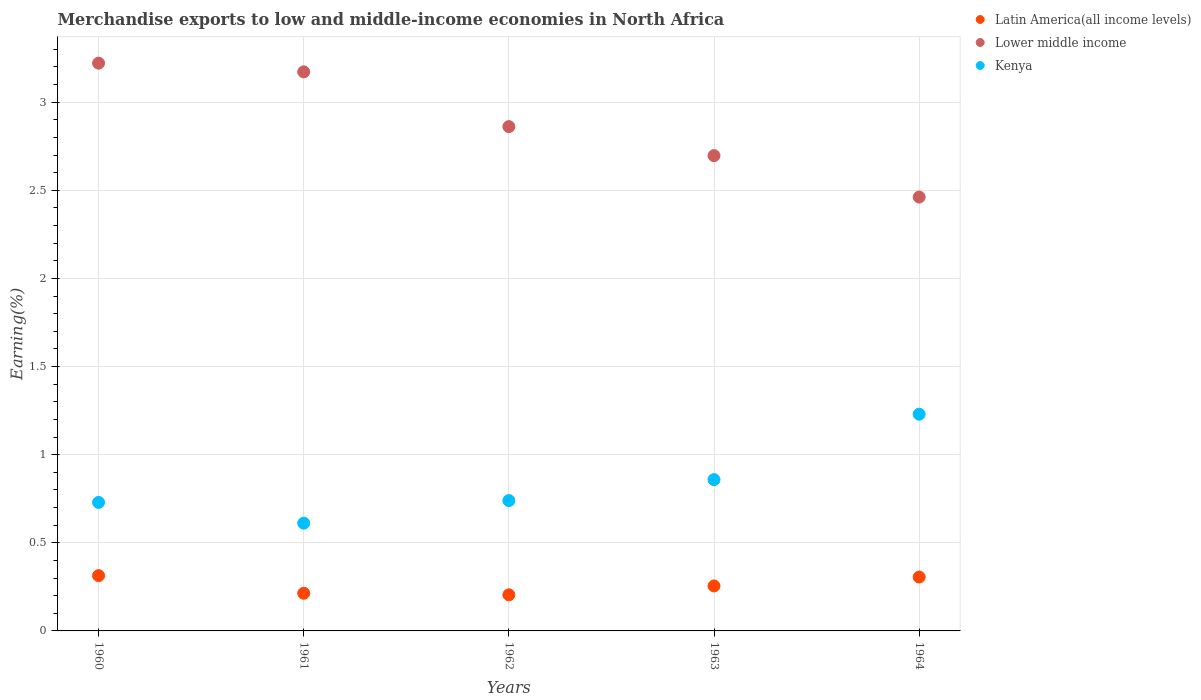How many different coloured dotlines are there?
Your response must be concise. 3. What is the percentage of amount earned from merchandise exports in Latin America(all income levels) in 1962?
Keep it short and to the point. 0.2. Across all years, what is the maximum percentage of amount earned from merchandise exports in Kenya?
Make the answer very short. 1.23. Across all years, what is the minimum percentage of amount earned from merchandise exports in Lower middle income?
Offer a terse response. 2.46. In which year was the percentage of amount earned from merchandise exports in Lower middle income maximum?
Your response must be concise. 1960. In which year was the percentage of amount earned from merchandise exports in Lower middle income minimum?
Your response must be concise. 1964. What is the total percentage of amount earned from merchandise exports in Kenya in the graph?
Your answer should be very brief. 4.17. What is the difference between the percentage of amount earned from merchandise exports in Lower middle income in 1960 and that in 1962?
Offer a very short reply. 0.36. What is the difference between the percentage of amount earned from merchandise exports in Latin America(all income levels) in 1962 and the percentage of amount earned from merchandise exports in Kenya in 1960?
Ensure brevity in your answer.  -0.52. What is the average percentage of amount earned from merchandise exports in Kenya per year?
Ensure brevity in your answer.  0.83. In the year 1963, what is the difference between the percentage of amount earned from merchandise exports in Kenya and percentage of amount earned from merchandise exports in Latin America(all income levels)?
Provide a succinct answer. 0.6. In how many years, is the percentage of amount earned from merchandise exports in Lower middle income greater than 1.5 %?
Your answer should be very brief. 5. What is the ratio of the percentage of amount earned from merchandise exports in Lower middle income in 1960 to that in 1964?
Offer a very short reply. 1.31. Is the difference between the percentage of amount earned from merchandise exports in Kenya in 1960 and 1963 greater than the difference between the percentage of amount earned from merchandise exports in Latin America(all income levels) in 1960 and 1963?
Your answer should be very brief. No. What is the difference between the highest and the second highest percentage of amount earned from merchandise exports in Lower middle income?
Your answer should be very brief. 0.05. What is the difference between the highest and the lowest percentage of amount earned from merchandise exports in Latin America(all income levels)?
Make the answer very short. 0.11. In how many years, is the percentage of amount earned from merchandise exports in Lower middle income greater than the average percentage of amount earned from merchandise exports in Lower middle income taken over all years?
Keep it short and to the point. 2. Is the percentage of amount earned from merchandise exports in Lower middle income strictly less than the percentage of amount earned from merchandise exports in Latin America(all income levels) over the years?
Provide a succinct answer. No. How many dotlines are there?
Offer a very short reply. 3. Does the graph contain any zero values?
Make the answer very short. No. Does the graph contain grids?
Offer a terse response. Yes. Where does the legend appear in the graph?
Ensure brevity in your answer.  Top right. How are the legend labels stacked?
Your response must be concise. Vertical. What is the title of the graph?
Offer a very short reply. Merchandise exports to low and middle-income economies in North Africa. What is the label or title of the X-axis?
Your response must be concise. Years. What is the label or title of the Y-axis?
Provide a short and direct response. Earning(%). What is the Earning(%) of Latin America(all income levels) in 1960?
Ensure brevity in your answer.  0.31. What is the Earning(%) in Lower middle income in 1960?
Make the answer very short. 3.22. What is the Earning(%) in Kenya in 1960?
Your response must be concise. 0.73. What is the Earning(%) in Latin America(all income levels) in 1961?
Provide a short and direct response. 0.21. What is the Earning(%) of Lower middle income in 1961?
Offer a very short reply. 3.17. What is the Earning(%) in Kenya in 1961?
Offer a very short reply. 0.61. What is the Earning(%) of Latin America(all income levels) in 1962?
Your answer should be very brief. 0.2. What is the Earning(%) in Lower middle income in 1962?
Offer a very short reply. 2.86. What is the Earning(%) in Kenya in 1962?
Provide a succinct answer. 0.74. What is the Earning(%) in Latin America(all income levels) in 1963?
Offer a very short reply. 0.26. What is the Earning(%) in Lower middle income in 1963?
Provide a short and direct response. 2.7. What is the Earning(%) in Kenya in 1963?
Provide a succinct answer. 0.86. What is the Earning(%) in Latin America(all income levels) in 1964?
Make the answer very short. 0.31. What is the Earning(%) of Lower middle income in 1964?
Provide a short and direct response. 2.46. What is the Earning(%) in Kenya in 1964?
Your answer should be compact. 1.23. Across all years, what is the maximum Earning(%) of Latin America(all income levels)?
Offer a terse response. 0.31. Across all years, what is the maximum Earning(%) in Lower middle income?
Provide a short and direct response. 3.22. Across all years, what is the maximum Earning(%) in Kenya?
Your response must be concise. 1.23. Across all years, what is the minimum Earning(%) of Latin America(all income levels)?
Your response must be concise. 0.2. Across all years, what is the minimum Earning(%) in Lower middle income?
Offer a terse response. 2.46. Across all years, what is the minimum Earning(%) of Kenya?
Your response must be concise. 0.61. What is the total Earning(%) in Latin America(all income levels) in the graph?
Your response must be concise. 1.29. What is the total Earning(%) in Lower middle income in the graph?
Your response must be concise. 14.41. What is the total Earning(%) in Kenya in the graph?
Provide a succinct answer. 4.17. What is the difference between the Earning(%) in Latin America(all income levels) in 1960 and that in 1961?
Your answer should be compact. 0.1. What is the difference between the Earning(%) of Lower middle income in 1960 and that in 1961?
Offer a very short reply. 0.05. What is the difference between the Earning(%) in Kenya in 1960 and that in 1961?
Your response must be concise. 0.12. What is the difference between the Earning(%) of Latin America(all income levels) in 1960 and that in 1962?
Your answer should be very brief. 0.11. What is the difference between the Earning(%) in Lower middle income in 1960 and that in 1962?
Make the answer very short. 0.36. What is the difference between the Earning(%) of Kenya in 1960 and that in 1962?
Your response must be concise. -0.01. What is the difference between the Earning(%) in Latin America(all income levels) in 1960 and that in 1963?
Give a very brief answer. 0.06. What is the difference between the Earning(%) of Lower middle income in 1960 and that in 1963?
Your answer should be very brief. 0.52. What is the difference between the Earning(%) of Kenya in 1960 and that in 1963?
Provide a succinct answer. -0.13. What is the difference between the Earning(%) in Latin America(all income levels) in 1960 and that in 1964?
Offer a very short reply. 0.01. What is the difference between the Earning(%) of Lower middle income in 1960 and that in 1964?
Your answer should be very brief. 0.76. What is the difference between the Earning(%) of Kenya in 1960 and that in 1964?
Make the answer very short. -0.5. What is the difference between the Earning(%) of Latin America(all income levels) in 1961 and that in 1962?
Ensure brevity in your answer.  0.01. What is the difference between the Earning(%) of Lower middle income in 1961 and that in 1962?
Offer a terse response. 0.31. What is the difference between the Earning(%) of Kenya in 1961 and that in 1962?
Provide a succinct answer. -0.13. What is the difference between the Earning(%) of Latin America(all income levels) in 1961 and that in 1963?
Your response must be concise. -0.04. What is the difference between the Earning(%) of Lower middle income in 1961 and that in 1963?
Your response must be concise. 0.48. What is the difference between the Earning(%) in Kenya in 1961 and that in 1963?
Make the answer very short. -0.25. What is the difference between the Earning(%) of Latin America(all income levels) in 1961 and that in 1964?
Make the answer very short. -0.09. What is the difference between the Earning(%) in Lower middle income in 1961 and that in 1964?
Make the answer very short. 0.71. What is the difference between the Earning(%) in Kenya in 1961 and that in 1964?
Your answer should be very brief. -0.62. What is the difference between the Earning(%) of Latin America(all income levels) in 1962 and that in 1963?
Provide a succinct answer. -0.05. What is the difference between the Earning(%) of Lower middle income in 1962 and that in 1963?
Your response must be concise. 0.16. What is the difference between the Earning(%) of Kenya in 1962 and that in 1963?
Offer a very short reply. -0.12. What is the difference between the Earning(%) of Latin America(all income levels) in 1962 and that in 1964?
Give a very brief answer. -0.1. What is the difference between the Earning(%) in Lower middle income in 1962 and that in 1964?
Offer a very short reply. 0.4. What is the difference between the Earning(%) of Kenya in 1962 and that in 1964?
Ensure brevity in your answer.  -0.49. What is the difference between the Earning(%) in Latin America(all income levels) in 1963 and that in 1964?
Your response must be concise. -0.05. What is the difference between the Earning(%) of Lower middle income in 1963 and that in 1964?
Your response must be concise. 0.23. What is the difference between the Earning(%) in Kenya in 1963 and that in 1964?
Offer a terse response. -0.37. What is the difference between the Earning(%) of Latin America(all income levels) in 1960 and the Earning(%) of Lower middle income in 1961?
Make the answer very short. -2.86. What is the difference between the Earning(%) in Latin America(all income levels) in 1960 and the Earning(%) in Kenya in 1961?
Your response must be concise. -0.3. What is the difference between the Earning(%) in Lower middle income in 1960 and the Earning(%) in Kenya in 1961?
Provide a succinct answer. 2.61. What is the difference between the Earning(%) in Latin America(all income levels) in 1960 and the Earning(%) in Lower middle income in 1962?
Your response must be concise. -2.55. What is the difference between the Earning(%) of Latin America(all income levels) in 1960 and the Earning(%) of Kenya in 1962?
Your response must be concise. -0.43. What is the difference between the Earning(%) of Lower middle income in 1960 and the Earning(%) of Kenya in 1962?
Ensure brevity in your answer.  2.48. What is the difference between the Earning(%) of Latin America(all income levels) in 1960 and the Earning(%) of Lower middle income in 1963?
Ensure brevity in your answer.  -2.38. What is the difference between the Earning(%) in Latin America(all income levels) in 1960 and the Earning(%) in Kenya in 1963?
Offer a terse response. -0.54. What is the difference between the Earning(%) in Lower middle income in 1960 and the Earning(%) in Kenya in 1963?
Make the answer very short. 2.36. What is the difference between the Earning(%) in Latin America(all income levels) in 1960 and the Earning(%) in Lower middle income in 1964?
Offer a terse response. -2.15. What is the difference between the Earning(%) of Latin America(all income levels) in 1960 and the Earning(%) of Kenya in 1964?
Your response must be concise. -0.92. What is the difference between the Earning(%) in Lower middle income in 1960 and the Earning(%) in Kenya in 1964?
Your answer should be very brief. 1.99. What is the difference between the Earning(%) of Latin America(all income levels) in 1961 and the Earning(%) of Lower middle income in 1962?
Ensure brevity in your answer.  -2.65. What is the difference between the Earning(%) of Latin America(all income levels) in 1961 and the Earning(%) of Kenya in 1962?
Offer a terse response. -0.53. What is the difference between the Earning(%) of Lower middle income in 1961 and the Earning(%) of Kenya in 1962?
Keep it short and to the point. 2.43. What is the difference between the Earning(%) of Latin America(all income levels) in 1961 and the Earning(%) of Lower middle income in 1963?
Offer a very short reply. -2.48. What is the difference between the Earning(%) of Latin America(all income levels) in 1961 and the Earning(%) of Kenya in 1963?
Keep it short and to the point. -0.64. What is the difference between the Earning(%) of Lower middle income in 1961 and the Earning(%) of Kenya in 1963?
Your answer should be compact. 2.31. What is the difference between the Earning(%) in Latin America(all income levels) in 1961 and the Earning(%) in Lower middle income in 1964?
Ensure brevity in your answer.  -2.25. What is the difference between the Earning(%) of Latin America(all income levels) in 1961 and the Earning(%) of Kenya in 1964?
Provide a succinct answer. -1.02. What is the difference between the Earning(%) in Lower middle income in 1961 and the Earning(%) in Kenya in 1964?
Your answer should be very brief. 1.94. What is the difference between the Earning(%) in Latin America(all income levels) in 1962 and the Earning(%) in Lower middle income in 1963?
Offer a terse response. -2.49. What is the difference between the Earning(%) in Latin America(all income levels) in 1962 and the Earning(%) in Kenya in 1963?
Ensure brevity in your answer.  -0.65. What is the difference between the Earning(%) of Lower middle income in 1962 and the Earning(%) of Kenya in 1963?
Give a very brief answer. 2. What is the difference between the Earning(%) in Latin America(all income levels) in 1962 and the Earning(%) in Lower middle income in 1964?
Keep it short and to the point. -2.26. What is the difference between the Earning(%) in Latin America(all income levels) in 1962 and the Earning(%) in Kenya in 1964?
Keep it short and to the point. -1.02. What is the difference between the Earning(%) of Lower middle income in 1962 and the Earning(%) of Kenya in 1964?
Offer a very short reply. 1.63. What is the difference between the Earning(%) in Latin America(all income levels) in 1963 and the Earning(%) in Lower middle income in 1964?
Offer a terse response. -2.21. What is the difference between the Earning(%) in Latin America(all income levels) in 1963 and the Earning(%) in Kenya in 1964?
Give a very brief answer. -0.97. What is the difference between the Earning(%) of Lower middle income in 1963 and the Earning(%) of Kenya in 1964?
Keep it short and to the point. 1.47. What is the average Earning(%) of Latin America(all income levels) per year?
Give a very brief answer. 0.26. What is the average Earning(%) of Lower middle income per year?
Keep it short and to the point. 2.88. What is the average Earning(%) in Kenya per year?
Keep it short and to the point. 0.83. In the year 1960, what is the difference between the Earning(%) of Latin America(all income levels) and Earning(%) of Lower middle income?
Your answer should be compact. -2.91. In the year 1960, what is the difference between the Earning(%) of Latin America(all income levels) and Earning(%) of Kenya?
Your response must be concise. -0.42. In the year 1960, what is the difference between the Earning(%) of Lower middle income and Earning(%) of Kenya?
Provide a succinct answer. 2.49. In the year 1961, what is the difference between the Earning(%) of Latin America(all income levels) and Earning(%) of Lower middle income?
Your answer should be compact. -2.96. In the year 1961, what is the difference between the Earning(%) in Latin America(all income levels) and Earning(%) in Kenya?
Make the answer very short. -0.4. In the year 1961, what is the difference between the Earning(%) in Lower middle income and Earning(%) in Kenya?
Make the answer very short. 2.56. In the year 1962, what is the difference between the Earning(%) of Latin America(all income levels) and Earning(%) of Lower middle income?
Offer a very short reply. -2.66. In the year 1962, what is the difference between the Earning(%) in Latin America(all income levels) and Earning(%) in Kenya?
Provide a succinct answer. -0.53. In the year 1962, what is the difference between the Earning(%) in Lower middle income and Earning(%) in Kenya?
Your answer should be very brief. 2.12. In the year 1963, what is the difference between the Earning(%) of Latin America(all income levels) and Earning(%) of Lower middle income?
Provide a short and direct response. -2.44. In the year 1963, what is the difference between the Earning(%) in Latin America(all income levels) and Earning(%) in Kenya?
Provide a short and direct response. -0.6. In the year 1963, what is the difference between the Earning(%) of Lower middle income and Earning(%) of Kenya?
Your answer should be very brief. 1.84. In the year 1964, what is the difference between the Earning(%) in Latin America(all income levels) and Earning(%) in Lower middle income?
Your response must be concise. -2.16. In the year 1964, what is the difference between the Earning(%) in Latin America(all income levels) and Earning(%) in Kenya?
Offer a terse response. -0.92. In the year 1964, what is the difference between the Earning(%) of Lower middle income and Earning(%) of Kenya?
Give a very brief answer. 1.23. What is the ratio of the Earning(%) in Latin America(all income levels) in 1960 to that in 1961?
Give a very brief answer. 1.47. What is the ratio of the Earning(%) of Lower middle income in 1960 to that in 1961?
Give a very brief answer. 1.02. What is the ratio of the Earning(%) of Kenya in 1960 to that in 1961?
Offer a very short reply. 1.19. What is the ratio of the Earning(%) in Latin America(all income levels) in 1960 to that in 1962?
Ensure brevity in your answer.  1.53. What is the ratio of the Earning(%) in Lower middle income in 1960 to that in 1962?
Your answer should be compact. 1.13. What is the ratio of the Earning(%) of Kenya in 1960 to that in 1962?
Ensure brevity in your answer.  0.99. What is the ratio of the Earning(%) in Latin America(all income levels) in 1960 to that in 1963?
Your answer should be compact. 1.23. What is the ratio of the Earning(%) in Lower middle income in 1960 to that in 1963?
Give a very brief answer. 1.19. What is the ratio of the Earning(%) of Kenya in 1960 to that in 1963?
Ensure brevity in your answer.  0.85. What is the ratio of the Earning(%) of Latin America(all income levels) in 1960 to that in 1964?
Keep it short and to the point. 1.03. What is the ratio of the Earning(%) of Lower middle income in 1960 to that in 1964?
Keep it short and to the point. 1.31. What is the ratio of the Earning(%) in Kenya in 1960 to that in 1964?
Provide a succinct answer. 0.59. What is the ratio of the Earning(%) of Latin America(all income levels) in 1961 to that in 1962?
Offer a terse response. 1.04. What is the ratio of the Earning(%) in Lower middle income in 1961 to that in 1962?
Offer a terse response. 1.11. What is the ratio of the Earning(%) of Kenya in 1961 to that in 1962?
Offer a very short reply. 0.83. What is the ratio of the Earning(%) in Latin America(all income levels) in 1961 to that in 1963?
Your response must be concise. 0.84. What is the ratio of the Earning(%) of Lower middle income in 1961 to that in 1963?
Give a very brief answer. 1.18. What is the ratio of the Earning(%) in Kenya in 1961 to that in 1963?
Offer a terse response. 0.71. What is the ratio of the Earning(%) in Latin America(all income levels) in 1961 to that in 1964?
Give a very brief answer. 0.7. What is the ratio of the Earning(%) in Lower middle income in 1961 to that in 1964?
Make the answer very short. 1.29. What is the ratio of the Earning(%) in Kenya in 1961 to that in 1964?
Ensure brevity in your answer.  0.5. What is the ratio of the Earning(%) in Latin America(all income levels) in 1962 to that in 1963?
Offer a terse response. 0.8. What is the ratio of the Earning(%) of Lower middle income in 1962 to that in 1963?
Give a very brief answer. 1.06. What is the ratio of the Earning(%) in Kenya in 1962 to that in 1963?
Ensure brevity in your answer.  0.86. What is the ratio of the Earning(%) in Latin America(all income levels) in 1962 to that in 1964?
Offer a very short reply. 0.67. What is the ratio of the Earning(%) in Lower middle income in 1962 to that in 1964?
Make the answer very short. 1.16. What is the ratio of the Earning(%) of Kenya in 1962 to that in 1964?
Your answer should be very brief. 0.6. What is the ratio of the Earning(%) of Latin America(all income levels) in 1963 to that in 1964?
Your answer should be very brief. 0.83. What is the ratio of the Earning(%) of Lower middle income in 1963 to that in 1964?
Provide a short and direct response. 1.1. What is the ratio of the Earning(%) of Kenya in 1963 to that in 1964?
Keep it short and to the point. 0.7. What is the difference between the highest and the second highest Earning(%) in Latin America(all income levels)?
Provide a succinct answer. 0.01. What is the difference between the highest and the second highest Earning(%) in Lower middle income?
Your answer should be compact. 0.05. What is the difference between the highest and the second highest Earning(%) of Kenya?
Your answer should be compact. 0.37. What is the difference between the highest and the lowest Earning(%) in Latin America(all income levels)?
Keep it short and to the point. 0.11. What is the difference between the highest and the lowest Earning(%) of Lower middle income?
Offer a very short reply. 0.76. What is the difference between the highest and the lowest Earning(%) in Kenya?
Your answer should be compact. 0.62. 